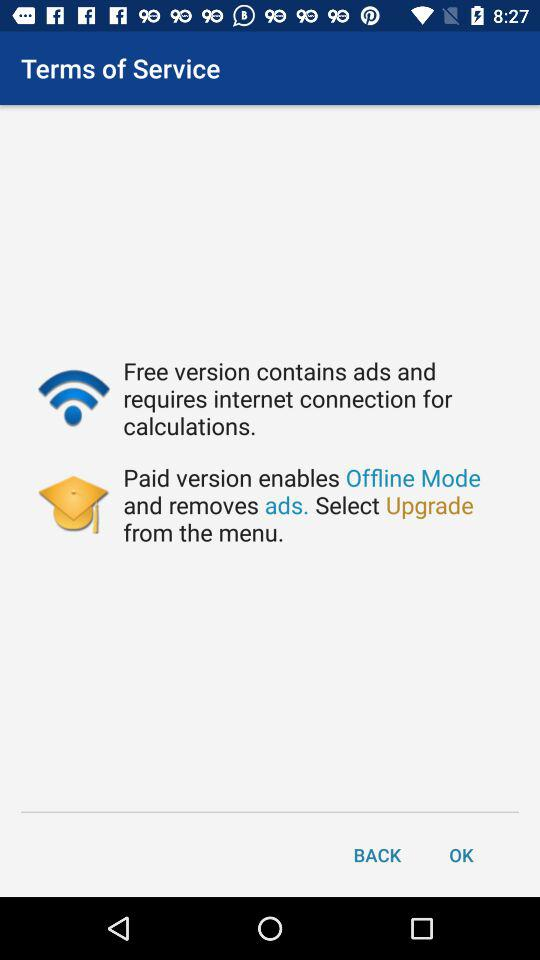Which version of the app requires internet connection for calculations?
Answer the question using a single word or phrase. Free 